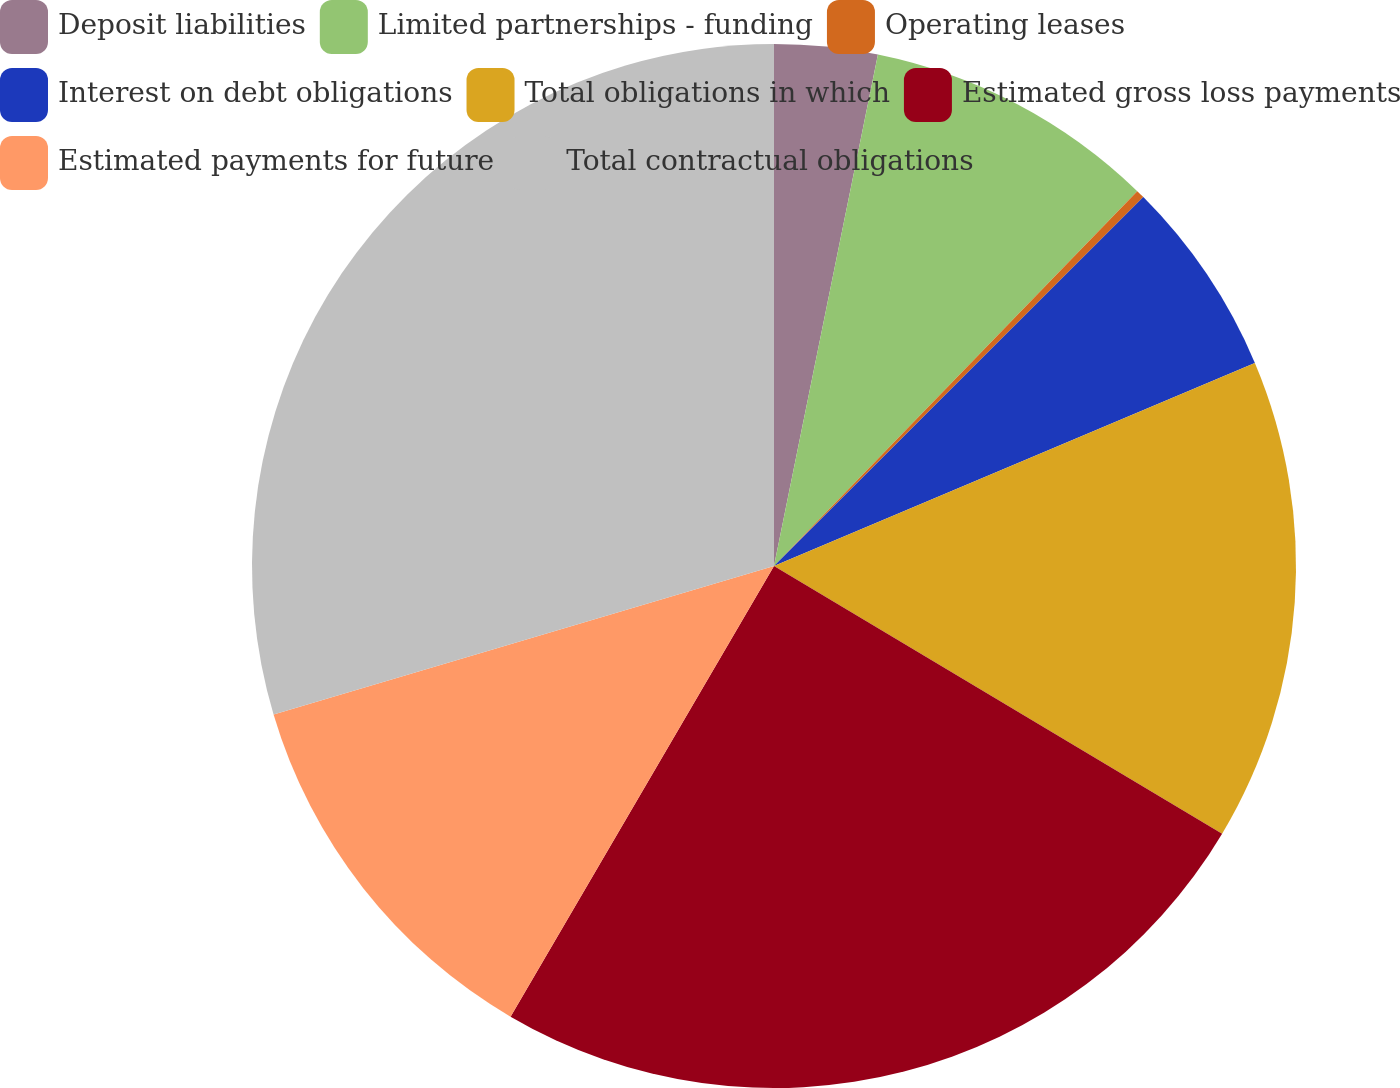Convert chart to OTSL. <chart><loc_0><loc_0><loc_500><loc_500><pie_chart><fcel>Deposit liabilities<fcel>Limited partnerships - funding<fcel>Operating leases<fcel>Interest on debt obligations<fcel>Total obligations in which<fcel>Estimated gross loss payments<fcel>Estimated payments for future<fcel>Total contractual obligations<nl><fcel>3.19%<fcel>9.06%<fcel>0.26%<fcel>6.13%<fcel>14.93%<fcel>24.85%<fcel>11.99%<fcel>29.59%<nl></chart> 